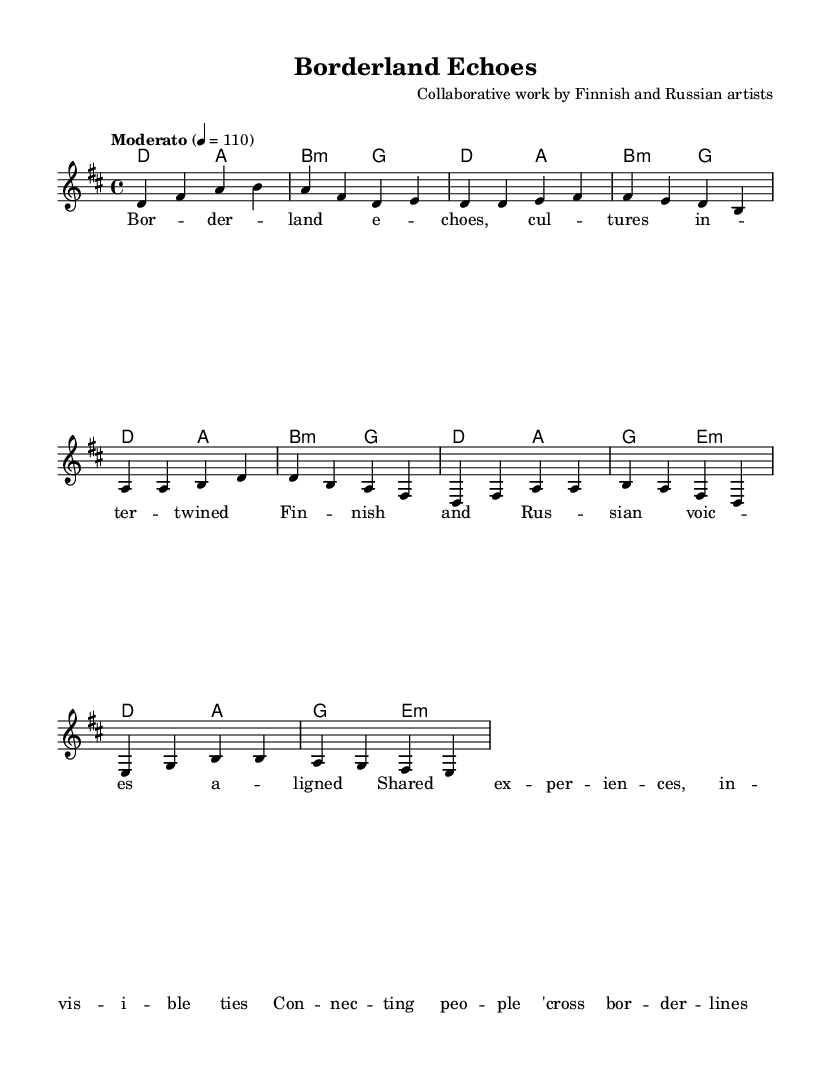What is the key signature of this music? The key signature is D major, which has two sharps, F# and C#. This can be deduced from the presence of the sharp symbols at the beginning of the staff, indicating it is in D major.
Answer: D major What is the time signature of this music? The time signature is 4/4, denoting four quarter-note beats per measure. This is shown at the beginning of the piece, where the numbers indicate the beat structure.
Answer: 4/4 What is the tempo marking for this piece? The tempo marking is Moderato, which typically refers to a moderate speed. The BPM value, 110, is provided next to the tempo marking, giving a specific speed for performance.
Answer: Moderato How many measures are in the verse section? The verse section contains four measures, which can be counted in the notation where the melody and harmonies are outlined labeled as the "Verse" section.
Answer: Four What is the chord used in the chorus? The chorus consists of the chords D, A, G, and E minor. Each chord is identified through the chord symbols placed above the notation, indicating the harmonic structure of that section.
Answer: D, A, G, E minor What do the lyrics of the song reflect? The lyrics reflect themes of shared experiences and cultural connections across borders, as indicated by the phrases and words used in the text under the melody. This points to the collaboration between Finnish and Russian artists.
Answer: Shared experiences 